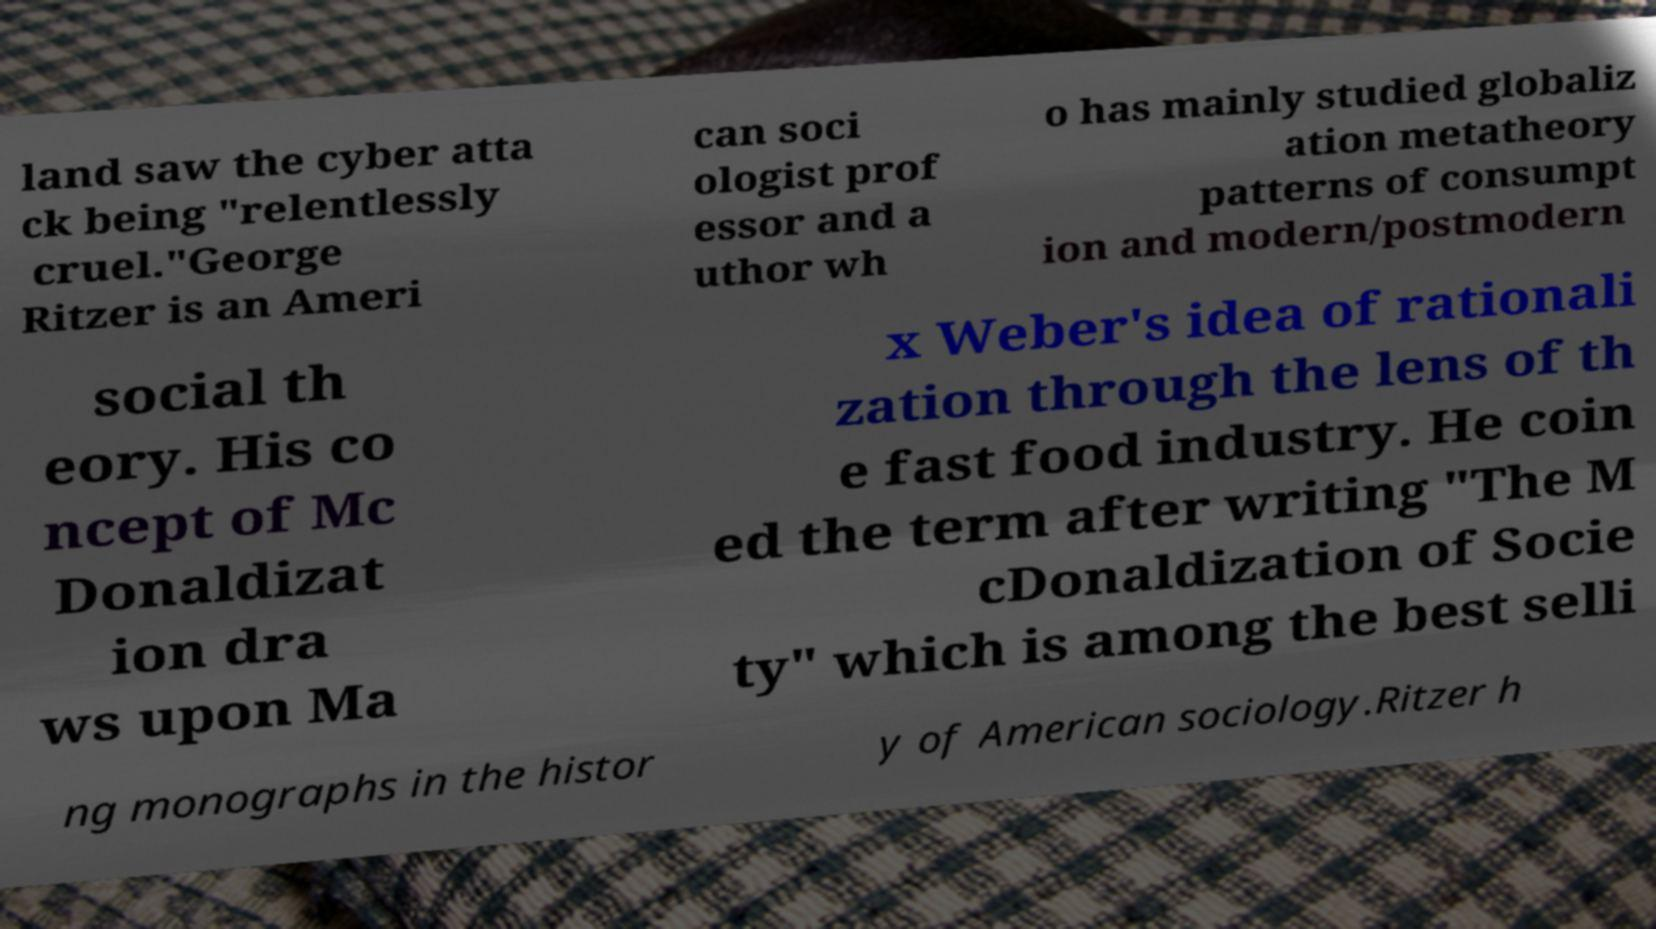Can you read and provide the text displayed in the image?This photo seems to have some interesting text. Can you extract and type it out for me? land saw the cyber atta ck being "relentlessly cruel."George Ritzer is an Ameri can soci ologist prof essor and a uthor wh o has mainly studied globaliz ation metatheory patterns of consumpt ion and modern/postmodern social th eory. His co ncept of Mc Donaldizat ion dra ws upon Ma x Weber's idea of rationali zation through the lens of th e fast food industry. He coin ed the term after writing "The M cDonaldization of Socie ty" which is among the best selli ng monographs in the histor y of American sociology.Ritzer h 